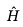Convert formula to latex. <formula><loc_0><loc_0><loc_500><loc_500>\hat { H }</formula> 